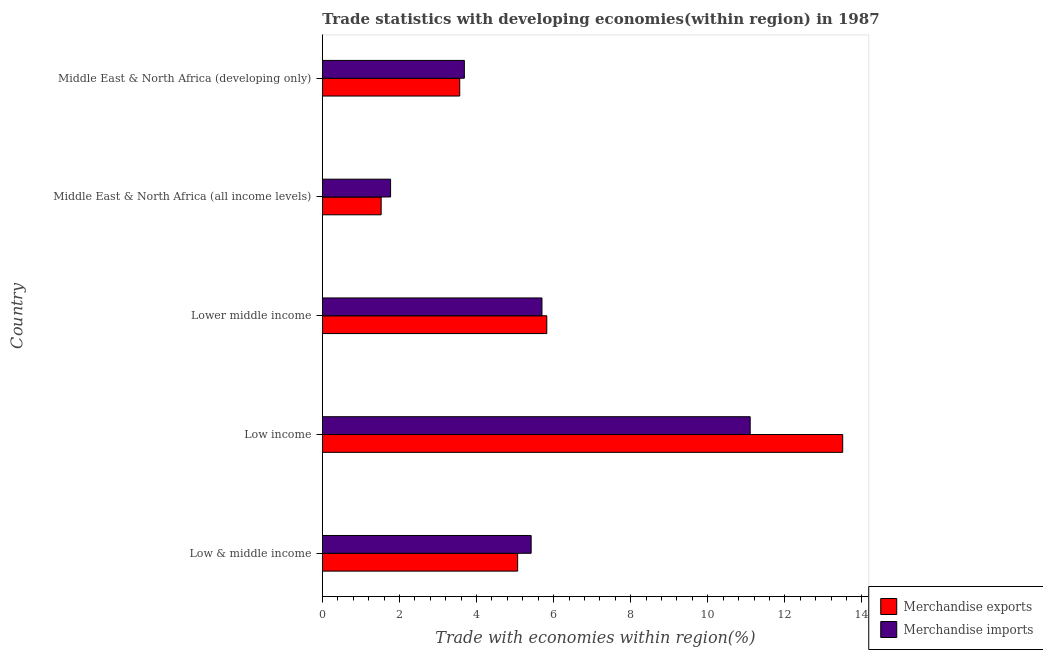How many different coloured bars are there?
Keep it short and to the point. 2. How many groups of bars are there?
Keep it short and to the point. 5. Are the number of bars per tick equal to the number of legend labels?
Provide a succinct answer. Yes. What is the label of the 5th group of bars from the top?
Give a very brief answer. Low & middle income. What is the merchandise exports in Middle East & North Africa (all income levels)?
Make the answer very short. 1.53. Across all countries, what is the maximum merchandise imports?
Ensure brevity in your answer.  11.1. Across all countries, what is the minimum merchandise imports?
Provide a short and direct response. 1.77. In which country was the merchandise exports minimum?
Ensure brevity in your answer.  Middle East & North Africa (all income levels). What is the total merchandise exports in the graph?
Give a very brief answer. 29.48. What is the difference between the merchandise exports in Low & middle income and that in Lower middle income?
Give a very brief answer. -0.76. What is the difference between the merchandise imports in Middle East & North Africa (all income levels) and the merchandise exports in Middle East & North Africa (developing only)?
Make the answer very short. -1.79. What is the average merchandise imports per country?
Offer a terse response. 5.53. What is the difference between the merchandise imports and merchandise exports in Low & middle income?
Your response must be concise. 0.35. Is the difference between the merchandise imports in Low & middle income and Middle East & North Africa (developing only) greater than the difference between the merchandise exports in Low & middle income and Middle East & North Africa (developing only)?
Offer a very short reply. Yes. What is the difference between the highest and the second highest merchandise exports?
Give a very brief answer. 7.68. What is the difference between the highest and the lowest merchandise imports?
Your response must be concise. 9.33. In how many countries, is the merchandise imports greater than the average merchandise imports taken over all countries?
Ensure brevity in your answer.  2. What does the 1st bar from the top in Middle East & North Africa (developing only) represents?
Make the answer very short. Merchandise imports. What does the 2nd bar from the bottom in Low income represents?
Offer a terse response. Merchandise imports. How many countries are there in the graph?
Provide a short and direct response. 5. What is the difference between two consecutive major ticks on the X-axis?
Provide a succinct answer. 2. Does the graph contain any zero values?
Give a very brief answer. No. How many legend labels are there?
Offer a very short reply. 2. How are the legend labels stacked?
Provide a short and direct response. Vertical. What is the title of the graph?
Your answer should be compact. Trade statistics with developing economies(within region) in 1987. What is the label or title of the X-axis?
Offer a very short reply. Trade with economies within region(%). What is the label or title of the Y-axis?
Ensure brevity in your answer.  Country. What is the Trade with economies within region(%) in Merchandise exports in Low & middle income?
Ensure brevity in your answer.  5.07. What is the Trade with economies within region(%) in Merchandise imports in Low & middle income?
Offer a terse response. 5.42. What is the Trade with economies within region(%) in Merchandise exports in Low income?
Provide a succinct answer. 13.5. What is the Trade with economies within region(%) of Merchandise imports in Low income?
Your answer should be very brief. 11.1. What is the Trade with economies within region(%) of Merchandise exports in Lower middle income?
Keep it short and to the point. 5.82. What is the Trade with economies within region(%) of Merchandise imports in Lower middle income?
Provide a succinct answer. 5.7. What is the Trade with economies within region(%) in Merchandise exports in Middle East & North Africa (all income levels)?
Your answer should be compact. 1.53. What is the Trade with economies within region(%) of Merchandise imports in Middle East & North Africa (all income levels)?
Provide a succinct answer. 1.77. What is the Trade with economies within region(%) of Merchandise exports in Middle East & North Africa (developing only)?
Your answer should be compact. 3.57. What is the Trade with economies within region(%) in Merchandise imports in Middle East & North Africa (developing only)?
Give a very brief answer. 3.68. Across all countries, what is the maximum Trade with economies within region(%) of Merchandise exports?
Your answer should be very brief. 13.5. Across all countries, what is the maximum Trade with economies within region(%) of Merchandise imports?
Keep it short and to the point. 11.1. Across all countries, what is the minimum Trade with economies within region(%) in Merchandise exports?
Give a very brief answer. 1.53. Across all countries, what is the minimum Trade with economies within region(%) in Merchandise imports?
Give a very brief answer. 1.77. What is the total Trade with economies within region(%) of Merchandise exports in the graph?
Your response must be concise. 29.48. What is the total Trade with economies within region(%) of Merchandise imports in the graph?
Keep it short and to the point. 27.67. What is the difference between the Trade with economies within region(%) of Merchandise exports in Low & middle income and that in Low income?
Offer a very short reply. -8.43. What is the difference between the Trade with economies within region(%) in Merchandise imports in Low & middle income and that in Low income?
Offer a very short reply. -5.68. What is the difference between the Trade with economies within region(%) in Merchandise exports in Low & middle income and that in Lower middle income?
Make the answer very short. -0.76. What is the difference between the Trade with economies within region(%) of Merchandise imports in Low & middle income and that in Lower middle income?
Make the answer very short. -0.28. What is the difference between the Trade with economies within region(%) of Merchandise exports in Low & middle income and that in Middle East & North Africa (all income levels)?
Make the answer very short. 3.54. What is the difference between the Trade with economies within region(%) of Merchandise imports in Low & middle income and that in Middle East & North Africa (all income levels)?
Offer a terse response. 3.65. What is the difference between the Trade with economies within region(%) in Merchandise exports in Low & middle income and that in Middle East & North Africa (developing only)?
Ensure brevity in your answer.  1.5. What is the difference between the Trade with economies within region(%) in Merchandise imports in Low & middle income and that in Middle East & North Africa (developing only)?
Offer a very short reply. 1.73. What is the difference between the Trade with economies within region(%) in Merchandise exports in Low income and that in Lower middle income?
Offer a very short reply. 7.68. What is the difference between the Trade with economies within region(%) in Merchandise imports in Low income and that in Lower middle income?
Provide a succinct answer. 5.4. What is the difference between the Trade with economies within region(%) in Merchandise exports in Low income and that in Middle East & North Africa (all income levels)?
Provide a succinct answer. 11.97. What is the difference between the Trade with economies within region(%) of Merchandise imports in Low income and that in Middle East & North Africa (all income levels)?
Your answer should be very brief. 9.33. What is the difference between the Trade with economies within region(%) of Merchandise exports in Low income and that in Middle East & North Africa (developing only)?
Your answer should be compact. 9.94. What is the difference between the Trade with economies within region(%) of Merchandise imports in Low income and that in Middle East & North Africa (developing only)?
Offer a very short reply. 7.42. What is the difference between the Trade with economies within region(%) in Merchandise exports in Lower middle income and that in Middle East & North Africa (all income levels)?
Your answer should be very brief. 4.3. What is the difference between the Trade with economies within region(%) in Merchandise imports in Lower middle income and that in Middle East & North Africa (all income levels)?
Keep it short and to the point. 3.93. What is the difference between the Trade with economies within region(%) in Merchandise exports in Lower middle income and that in Middle East & North Africa (developing only)?
Keep it short and to the point. 2.26. What is the difference between the Trade with economies within region(%) in Merchandise imports in Lower middle income and that in Middle East & North Africa (developing only)?
Your answer should be very brief. 2.01. What is the difference between the Trade with economies within region(%) in Merchandise exports in Middle East & North Africa (all income levels) and that in Middle East & North Africa (developing only)?
Offer a very short reply. -2.04. What is the difference between the Trade with economies within region(%) in Merchandise imports in Middle East & North Africa (all income levels) and that in Middle East & North Africa (developing only)?
Offer a very short reply. -1.91. What is the difference between the Trade with economies within region(%) in Merchandise exports in Low & middle income and the Trade with economies within region(%) in Merchandise imports in Low income?
Provide a succinct answer. -6.03. What is the difference between the Trade with economies within region(%) in Merchandise exports in Low & middle income and the Trade with economies within region(%) in Merchandise imports in Lower middle income?
Your answer should be compact. -0.63. What is the difference between the Trade with economies within region(%) of Merchandise exports in Low & middle income and the Trade with economies within region(%) of Merchandise imports in Middle East & North Africa (all income levels)?
Offer a very short reply. 3.3. What is the difference between the Trade with economies within region(%) in Merchandise exports in Low & middle income and the Trade with economies within region(%) in Merchandise imports in Middle East & North Africa (developing only)?
Offer a terse response. 1.38. What is the difference between the Trade with economies within region(%) of Merchandise exports in Low income and the Trade with economies within region(%) of Merchandise imports in Lower middle income?
Provide a succinct answer. 7.8. What is the difference between the Trade with economies within region(%) of Merchandise exports in Low income and the Trade with economies within region(%) of Merchandise imports in Middle East & North Africa (all income levels)?
Offer a terse response. 11.73. What is the difference between the Trade with economies within region(%) in Merchandise exports in Low income and the Trade with economies within region(%) in Merchandise imports in Middle East & North Africa (developing only)?
Your answer should be very brief. 9.82. What is the difference between the Trade with economies within region(%) in Merchandise exports in Lower middle income and the Trade with economies within region(%) in Merchandise imports in Middle East & North Africa (all income levels)?
Ensure brevity in your answer.  4.05. What is the difference between the Trade with economies within region(%) of Merchandise exports in Lower middle income and the Trade with economies within region(%) of Merchandise imports in Middle East & North Africa (developing only)?
Offer a terse response. 2.14. What is the difference between the Trade with economies within region(%) in Merchandise exports in Middle East & North Africa (all income levels) and the Trade with economies within region(%) in Merchandise imports in Middle East & North Africa (developing only)?
Offer a very short reply. -2.16. What is the average Trade with economies within region(%) in Merchandise exports per country?
Offer a very short reply. 5.9. What is the average Trade with economies within region(%) of Merchandise imports per country?
Your answer should be very brief. 5.53. What is the difference between the Trade with economies within region(%) of Merchandise exports and Trade with economies within region(%) of Merchandise imports in Low & middle income?
Your response must be concise. -0.35. What is the difference between the Trade with economies within region(%) in Merchandise exports and Trade with economies within region(%) in Merchandise imports in Low income?
Keep it short and to the point. 2.4. What is the difference between the Trade with economies within region(%) in Merchandise exports and Trade with economies within region(%) in Merchandise imports in Lower middle income?
Offer a terse response. 0.13. What is the difference between the Trade with economies within region(%) in Merchandise exports and Trade with economies within region(%) in Merchandise imports in Middle East & North Africa (all income levels)?
Your answer should be very brief. -0.24. What is the difference between the Trade with economies within region(%) in Merchandise exports and Trade with economies within region(%) in Merchandise imports in Middle East & North Africa (developing only)?
Make the answer very short. -0.12. What is the ratio of the Trade with economies within region(%) in Merchandise exports in Low & middle income to that in Low income?
Your answer should be very brief. 0.38. What is the ratio of the Trade with economies within region(%) of Merchandise imports in Low & middle income to that in Low income?
Give a very brief answer. 0.49. What is the ratio of the Trade with economies within region(%) of Merchandise exports in Low & middle income to that in Lower middle income?
Your answer should be very brief. 0.87. What is the ratio of the Trade with economies within region(%) of Merchandise imports in Low & middle income to that in Lower middle income?
Ensure brevity in your answer.  0.95. What is the ratio of the Trade with economies within region(%) in Merchandise exports in Low & middle income to that in Middle East & North Africa (all income levels)?
Give a very brief answer. 3.32. What is the ratio of the Trade with economies within region(%) of Merchandise imports in Low & middle income to that in Middle East & North Africa (all income levels)?
Your answer should be very brief. 3.06. What is the ratio of the Trade with economies within region(%) of Merchandise exports in Low & middle income to that in Middle East & North Africa (developing only)?
Offer a terse response. 1.42. What is the ratio of the Trade with economies within region(%) of Merchandise imports in Low & middle income to that in Middle East & North Africa (developing only)?
Ensure brevity in your answer.  1.47. What is the ratio of the Trade with economies within region(%) of Merchandise exports in Low income to that in Lower middle income?
Your response must be concise. 2.32. What is the ratio of the Trade with economies within region(%) of Merchandise imports in Low income to that in Lower middle income?
Your answer should be very brief. 1.95. What is the ratio of the Trade with economies within region(%) in Merchandise exports in Low income to that in Middle East & North Africa (all income levels)?
Give a very brief answer. 8.85. What is the ratio of the Trade with economies within region(%) in Merchandise imports in Low income to that in Middle East & North Africa (all income levels)?
Give a very brief answer. 6.27. What is the ratio of the Trade with economies within region(%) of Merchandise exports in Low income to that in Middle East & North Africa (developing only)?
Offer a very short reply. 3.79. What is the ratio of the Trade with economies within region(%) in Merchandise imports in Low income to that in Middle East & North Africa (developing only)?
Your answer should be very brief. 3.01. What is the ratio of the Trade with economies within region(%) of Merchandise exports in Lower middle income to that in Middle East & North Africa (all income levels)?
Offer a terse response. 3.82. What is the ratio of the Trade with economies within region(%) of Merchandise imports in Lower middle income to that in Middle East & North Africa (all income levels)?
Ensure brevity in your answer.  3.22. What is the ratio of the Trade with economies within region(%) in Merchandise exports in Lower middle income to that in Middle East & North Africa (developing only)?
Provide a short and direct response. 1.63. What is the ratio of the Trade with economies within region(%) of Merchandise imports in Lower middle income to that in Middle East & North Africa (developing only)?
Your response must be concise. 1.55. What is the ratio of the Trade with economies within region(%) of Merchandise exports in Middle East & North Africa (all income levels) to that in Middle East & North Africa (developing only)?
Offer a very short reply. 0.43. What is the ratio of the Trade with economies within region(%) of Merchandise imports in Middle East & North Africa (all income levels) to that in Middle East & North Africa (developing only)?
Offer a terse response. 0.48. What is the difference between the highest and the second highest Trade with economies within region(%) in Merchandise exports?
Provide a succinct answer. 7.68. What is the difference between the highest and the second highest Trade with economies within region(%) in Merchandise imports?
Make the answer very short. 5.4. What is the difference between the highest and the lowest Trade with economies within region(%) of Merchandise exports?
Provide a succinct answer. 11.97. What is the difference between the highest and the lowest Trade with economies within region(%) in Merchandise imports?
Keep it short and to the point. 9.33. 